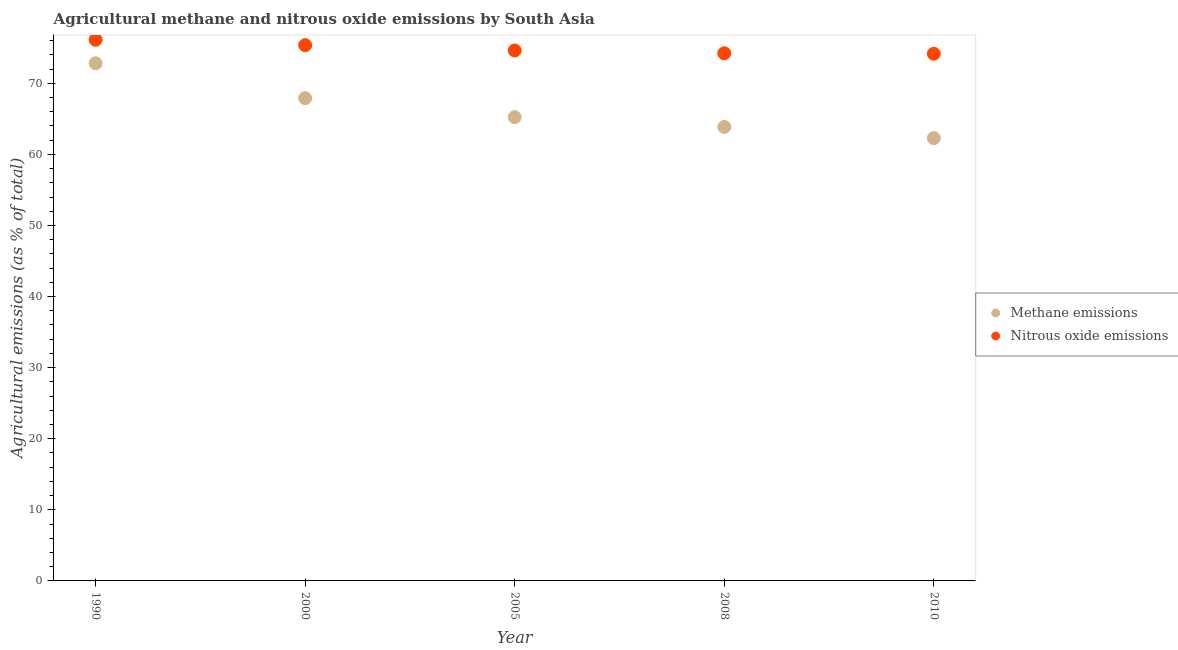Is the number of dotlines equal to the number of legend labels?
Keep it short and to the point. Yes. What is the amount of nitrous oxide emissions in 2000?
Your answer should be compact. 75.36. Across all years, what is the maximum amount of methane emissions?
Give a very brief answer. 72.82. Across all years, what is the minimum amount of methane emissions?
Make the answer very short. 62.29. In which year was the amount of methane emissions maximum?
Give a very brief answer. 1990. What is the total amount of nitrous oxide emissions in the graph?
Offer a terse response. 374.48. What is the difference between the amount of methane emissions in 2000 and that in 2010?
Keep it short and to the point. 5.62. What is the difference between the amount of nitrous oxide emissions in 2000 and the amount of methane emissions in 2005?
Offer a terse response. 10.13. What is the average amount of nitrous oxide emissions per year?
Provide a short and direct response. 74.9. In the year 1990, what is the difference between the amount of methane emissions and amount of nitrous oxide emissions?
Ensure brevity in your answer.  -3.3. What is the ratio of the amount of nitrous oxide emissions in 2005 to that in 2010?
Your answer should be very brief. 1.01. What is the difference between the highest and the second highest amount of methane emissions?
Make the answer very short. 4.91. What is the difference between the highest and the lowest amount of nitrous oxide emissions?
Ensure brevity in your answer.  1.96. In how many years, is the amount of methane emissions greater than the average amount of methane emissions taken over all years?
Provide a short and direct response. 2. Is the sum of the amount of methane emissions in 2000 and 2010 greater than the maximum amount of nitrous oxide emissions across all years?
Give a very brief answer. Yes. Is the amount of methane emissions strictly greater than the amount of nitrous oxide emissions over the years?
Your response must be concise. No. How many dotlines are there?
Provide a short and direct response. 2. How many years are there in the graph?
Keep it short and to the point. 5. Are the values on the major ticks of Y-axis written in scientific E-notation?
Offer a very short reply. No. How many legend labels are there?
Keep it short and to the point. 2. What is the title of the graph?
Offer a very short reply. Agricultural methane and nitrous oxide emissions by South Asia. Does "From Government" appear as one of the legend labels in the graph?
Your answer should be very brief. No. What is the label or title of the X-axis?
Ensure brevity in your answer.  Year. What is the label or title of the Y-axis?
Provide a short and direct response. Agricultural emissions (as % of total). What is the Agricultural emissions (as % of total) of Methane emissions in 1990?
Provide a succinct answer. 72.82. What is the Agricultural emissions (as % of total) of Nitrous oxide emissions in 1990?
Offer a terse response. 76.12. What is the Agricultural emissions (as % of total) of Methane emissions in 2000?
Your answer should be very brief. 67.91. What is the Agricultural emissions (as % of total) in Nitrous oxide emissions in 2000?
Keep it short and to the point. 75.36. What is the Agricultural emissions (as % of total) in Methane emissions in 2005?
Provide a short and direct response. 65.24. What is the Agricultural emissions (as % of total) of Nitrous oxide emissions in 2005?
Provide a short and direct response. 74.62. What is the Agricultural emissions (as % of total) in Methane emissions in 2008?
Keep it short and to the point. 63.86. What is the Agricultural emissions (as % of total) in Nitrous oxide emissions in 2008?
Make the answer very short. 74.22. What is the Agricultural emissions (as % of total) in Methane emissions in 2010?
Provide a succinct answer. 62.29. What is the Agricultural emissions (as % of total) of Nitrous oxide emissions in 2010?
Your answer should be very brief. 74.16. Across all years, what is the maximum Agricultural emissions (as % of total) in Methane emissions?
Your answer should be compact. 72.82. Across all years, what is the maximum Agricultural emissions (as % of total) in Nitrous oxide emissions?
Offer a terse response. 76.12. Across all years, what is the minimum Agricultural emissions (as % of total) of Methane emissions?
Your answer should be very brief. 62.29. Across all years, what is the minimum Agricultural emissions (as % of total) of Nitrous oxide emissions?
Make the answer very short. 74.16. What is the total Agricultural emissions (as % of total) in Methane emissions in the graph?
Keep it short and to the point. 332.11. What is the total Agricultural emissions (as % of total) of Nitrous oxide emissions in the graph?
Provide a succinct answer. 374.48. What is the difference between the Agricultural emissions (as % of total) of Methane emissions in 1990 and that in 2000?
Provide a succinct answer. 4.91. What is the difference between the Agricultural emissions (as % of total) in Nitrous oxide emissions in 1990 and that in 2000?
Provide a short and direct response. 0.76. What is the difference between the Agricultural emissions (as % of total) in Methane emissions in 1990 and that in 2005?
Your response must be concise. 7.58. What is the difference between the Agricultural emissions (as % of total) of Nitrous oxide emissions in 1990 and that in 2005?
Keep it short and to the point. 1.5. What is the difference between the Agricultural emissions (as % of total) in Methane emissions in 1990 and that in 2008?
Your response must be concise. 8.96. What is the difference between the Agricultural emissions (as % of total) in Nitrous oxide emissions in 1990 and that in 2008?
Make the answer very short. 1.9. What is the difference between the Agricultural emissions (as % of total) of Methane emissions in 1990 and that in 2010?
Your answer should be compact. 10.53. What is the difference between the Agricultural emissions (as % of total) of Nitrous oxide emissions in 1990 and that in 2010?
Offer a very short reply. 1.96. What is the difference between the Agricultural emissions (as % of total) of Methane emissions in 2000 and that in 2005?
Your answer should be very brief. 2.67. What is the difference between the Agricultural emissions (as % of total) of Nitrous oxide emissions in 2000 and that in 2005?
Offer a terse response. 0.75. What is the difference between the Agricultural emissions (as % of total) in Methane emissions in 2000 and that in 2008?
Keep it short and to the point. 4.04. What is the difference between the Agricultural emissions (as % of total) of Nitrous oxide emissions in 2000 and that in 2008?
Provide a short and direct response. 1.14. What is the difference between the Agricultural emissions (as % of total) in Methane emissions in 2000 and that in 2010?
Provide a succinct answer. 5.62. What is the difference between the Agricultural emissions (as % of total) in Nitrous oxide emissions in 2000 and that in 2010?
Provide a succinct answer. 1.2. What is the difference between the Agricultural emissions (as % of total) of Methane emissions in 2005 and that in 2008?
Ensure brevity in your answer.  1.37. What is the difference between the Agricultural emissions (as % of total) of Nitrous oxide emissions in 2005 and that in 2008?
Keep it short and to the point. 0.39. What is the difference between the Agricultural emissions (as % of total) of Methane emissions in 2005 and that in 2010?
Make the answer very short. 2.95. What is the difference between the Agricultural emissions (as % of total) in Nitrous oxide emissions in 2005 and that in 2010?
Offer a terse response. 0.46. What is the difference between the Agricultural emissions (as % of total) in Methane emissions in 2008 and that in 2010?
Offer a very short reply. 1.58. What is the difference between the Agricultural emissions (as % of total) of Nitrous oxide emissions in 2008 and that in 2010?
Offer a very short reply. 0.06. What is the difference between the Agricultural emissions (as % of total) of Methane emissions in 1990 and the Agricultural emissions (as % of total) of Nitrous oxide emissions in 2000?
Offer a very short reply. -2.54. What is the difference between the Agricultural emissions (as % of total) of Methane emissions in 1990 and the Agricultural emissions (as % of total) of Nitrous oxide emissions in 2005?
Your response must be concise. -1.8. What is the difference between the Agricultural emissions (as % of total) in Methane emissions in 1990 and the Agricultural emissions (as % of total) in Nitrous oxide emissions in 2008?
Ensure brevity in your answer.  -1.4. What is the difference between the Agricultural emissions (as % of total) of Methane emissions in 1990 and the Agricultural emissions (as % of total) of Nitrous oxide emissions in 2010?
Your response must be concise. -1.34. What is the difference between the Agricultural emissions (as % of total) in Methane emissions in 2000 and the Agricultural emissions (as % of total) in Nitrous oxide emissions in 2005?
Your answer should be compact. -6.71. What is the difference between the Agricultural emissions (as % of total) of Methane emissions in 2000 and the Agricultural emissions (as % of total) of Nitrous oxide emissions in 2008?
Offer a very short reply. -6.31. What is the difference between the Agricultural emissions (as % of total) of Methane emissions in 2000 and the Agricultural emissions (as % of total) of Nitrous oxide emissions in 2010?
Provide a succinct answer. -6.25. What is the difference between the Agricultural emissions (as % of total) of Methane emissions in 2005 and the Agricultural emissions (as % of total) of Nitrous oxide emissions in 2008?
Ensure brevity in your answer.  -8.98. What is the difference between the Agricultural emissions (as % of total) of Methane emissions in 2005 and the Agricultural emissions (as % of total) of Nitrous oxide emissions in 2010?
Provide a short and direct response. -8.92. What is the difference between the Agricultural emissions (as % of total) in Methane emissions in 2008 and the Agricultural emissions (as % of total) in Nitrous oxide emissions in 2010?
Offer a terse response. -10.3. What is the average Agricultural emissions (as % of total) of Methane emissions per year?
Your answer should be very brief. 66.42. What is the average Agricultural emissions (as % of total) of Nitrous oxide emissions per year?
Keep it short and to the point. 74.9. In the year 1990, what is the difference between the Agricultural emissions (as % of total) of Methane emissions and Agricultural emissions (as % of total) of Nitrous oxide emissions?
Give a very brief answer. -3.3. In the year 2000, what is the difference between the Agricultural emissions (as % of total) of Methane emissions and Agricultural emissions (as % of total) of Nitrous oxide emissions?
Ensure brevity in your answer.  -7.45. In the year 2005, what is the difference between the Agricultural emissions (as % of total) of Methane emissions and Agricultural emissions (as % of total) of Nitrous oxide emissions?
Provide a short and direct response. -9.38. In the year 2008, what is the difference between the Agricultural emissions (as % of total) of Methane emissions and Agricultural emissions (as % of total) of Nitrous oxide emissions?
Make the answer very short. -10.36. In the year 2010, what is the difference between the Agricultural emissions (as % of total) of Methane emissions and Agricultural emissions (as % of total) of Nitrous oxide emissions?
Offer a terse response. -11.87. What is the ratio of the Agricultural emissions (as % of total) of Methane emissions in 1990 to that in 2000?
Make the answer very short. 1.07. What is the ratio of the Agricultural emissions (as % of total) of Nitrous oxide emissions in 1990 to that in 2000?
Your answer should be very brief. 1.01. What is the ratio of the Agricultural emissions (as % of total) of Methane emissions in 1990 to that in 2005?
Your answer should be very brief. 1.12. What is the ratio of the Agricultural emissions (as % of total) of Nitrous oxide emissions in 1990 to that in 2005?
Make the answer very short. 1.02. What is the ratio of the Agricultural emissions (as % of total) in Methane emissions in 1990 to that in 2008?
Your answer should be compact. 1.14. What is the ratio of the Agricultural emissions (as % of total) in Nitrous oxide emissions in 1990 to that in 2008?
Keep it short and to the point. 1.03. What is the ratio of the Agricultural emissions (as % of total) in Methane emissions in 1990 to that in 2010?
Give a very brief answer. 1.17. What is the ratio of the Agricultural emissions (as % of total) in Nitrous oxide emissions in 1990 to that in 2010?
Make the answer very short. 1.03. What is the ratio of the Agricultural emissions (as % of total) in Methane emissions in 2000 to that in 2005?
Give a very brief answer. 1.04. What is the ratio of the Agricultural emissions (as % of total) of Nitrous oxide emissions in 2000 to that in 2005?
Your response must be concise. 1.01. What is the ratio of the Agricultural emissions (as % of total) of Methane emissions in 2000 to that in 2008?
Make the answer very short. 1.06. What is the ratio of the Agricultural emissions (as % of total) in Nitrous oxide emissions in 2000 to that in 2008?
Provide a short and direct response. 1.02. What is the ratio of the Agricultural emissions (as % of total) in Methane emissions in 2000 to that in 2010?
Your answer should be compact. 1.09. What is the ratio of the Agricultural emissions (as % of total) in Nitrous oxide emissions in 2000 to that in 2010?
Your answer should be very brief. 1.02. What is the ratio of the Agricultural emissions (as % of total) of Methane emissions in 2005 to that in 2008?
Ensure brevity in your answer.  1.02. What is the ratio of the Agricultural emissions (as % of total) in Methane emissions in 2005 to that in 2010?
Provide a short and direct response. 1.05. What is the ratio of the Agricultural emissions (as % of total) in Nitrous oxide emissions in 2005 to that in 2010?
Offer a terse response. 1.01. What is the ratio of the Agricultural emissions (as % of total) of Methane emissions in 2008 to that in 2010?
Keep it short and to the point. 1.03. What is the difference between the highest and the second highest Agricultural emissions (as % of total) in Methane emissions?
Provide a short and direct response. 4.91. What is the difference between the highest and the second highest Agricultural emissions (as % of total) in Nitrous oxide emissions?
Your answer should be very brief. 0.76. What is the difference between the highest and the lowest Agricultural emissions (as % of total) in Methane emissions?
Offer a very short reply. 10.53. What is the difference between the highest and the lowest Agricultural emissions (as % of total) in Nitrous oxide emissions?
Your response must be concise. 1.96. 